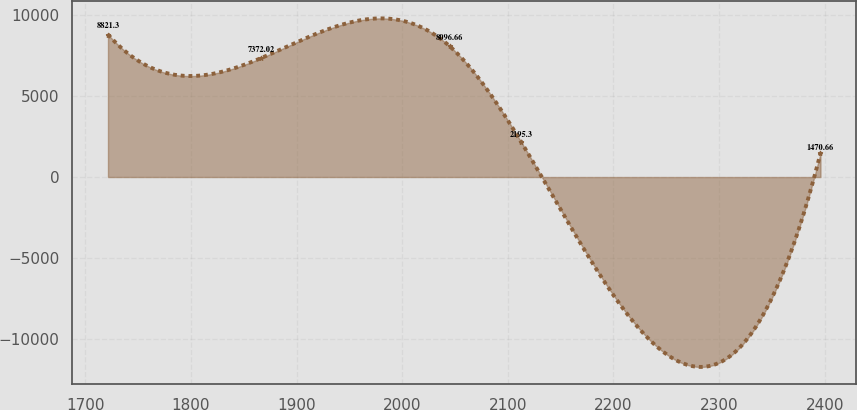Convert chart to OTSL. <chart><loc_0><loc_0><loc_500><loc_500><line_chart><ecel><fcel>Unnamed: 1<nl><fcel>1721.38<fcel>8821.3<nl><fcel>1866.7<fcel>7372.02<nl><fcel>2044.95<fcel>8096.66<nl><fcel>2112.42<fcel>2195.3<nl><fcel>2396.07<fcel>1470.66<nl></chart> 